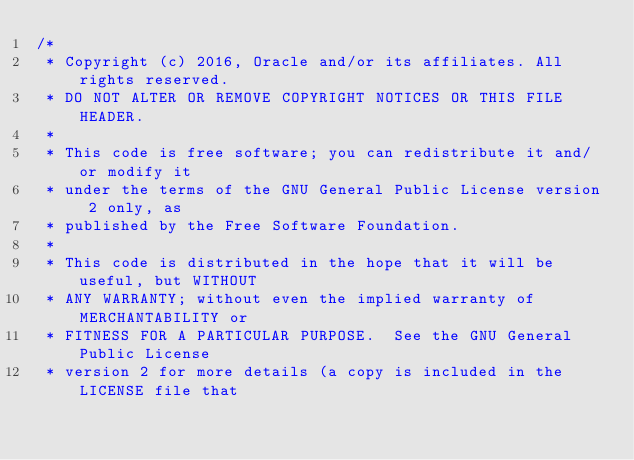Convert code to text. <code><loc_0><loc_0><loc_500><loc_500><_Java_>/*
 * Copyright (c) 2016, Oracle and/or its affiliates. All rights reserved.
 * DO NOT ALTER OR REMOVE COPYRIGHT NOTICES OR THIS FILE HEADER.
 *
 * This code is free software; you can redistribute it and/or modify it
 * under the terms of the GNU General Public License version 2 only, as
 * published by the Free Software Foundation.
 *
 * This code is distributed in the hope that it will be useful, but WITHOUT
 * ANY WARRANTY; without even the implied warranty of MERCHANTABILITY or
 * FITNESS FOR A PARTICULAR PURPOSE.  See the GNU General Public License
 * version 2 for more details (a copy is included in the LICENSE file that</code> 